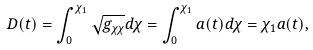Convert formula to latex. <formula><loc_0><loc_0><loc_500><loc_500>D ( t ) = \int _ { 0 } ^ { \chi _ { 1 } } \sqrt { g _ { \chi \chi } } d \chi = \int _ { 0 } ^ { \chi _ { 1 } } a ( t ) d \chi = \chi _ { 1 } a ( t ) ,</formula> 